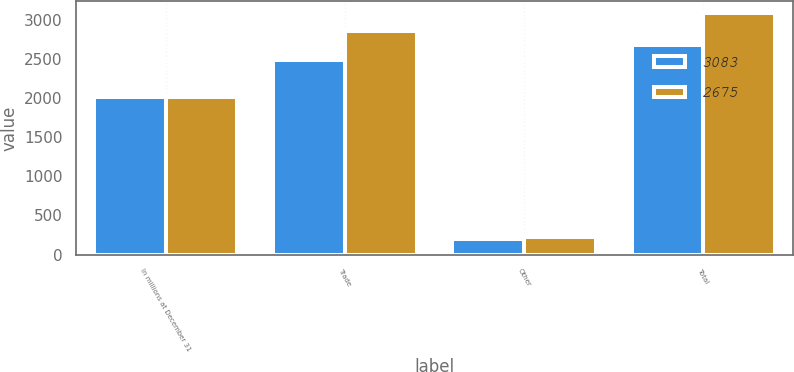<chart> <loc_0><loc_0><loc_500><loc_500><stacked_bar_chart><ecel><fcel>In millions at December 31<fcel>Trade<fcel>Other<fcel>Total<nl><fcel>3083<fcel>2015<fcel>2480<fcel>195<fcel>2675<nl><fcel>2675<fcel>2014<fcel>2860<fcel>223<fcel>3083<nl></chart> 